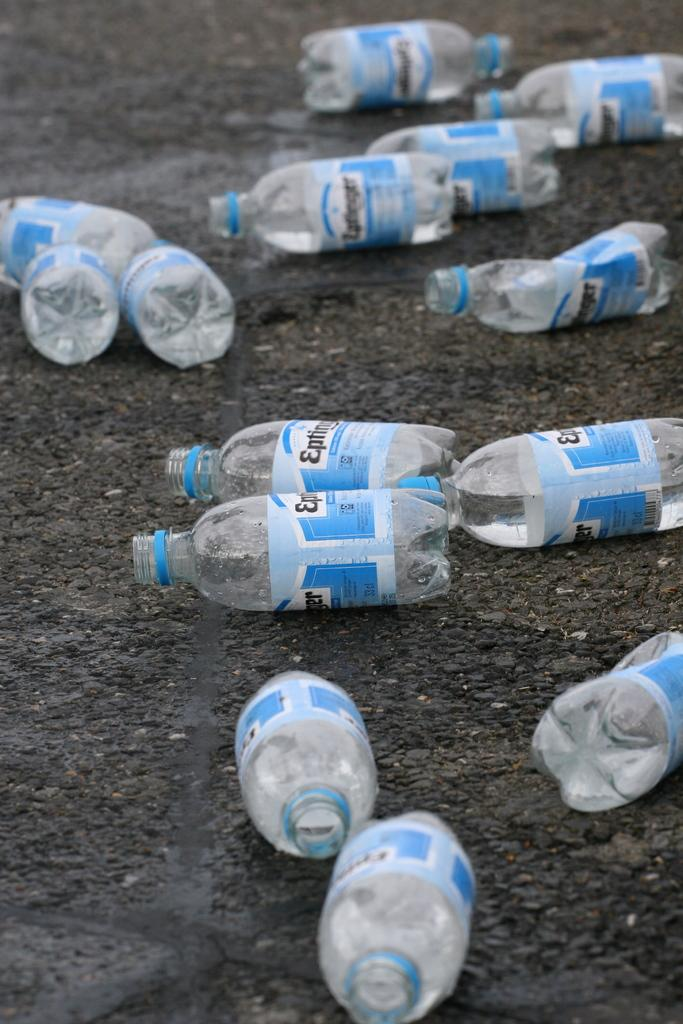<image>
Create a compact narrative representing the image presented. Several opened Eptinger water bottles litter the ground. 